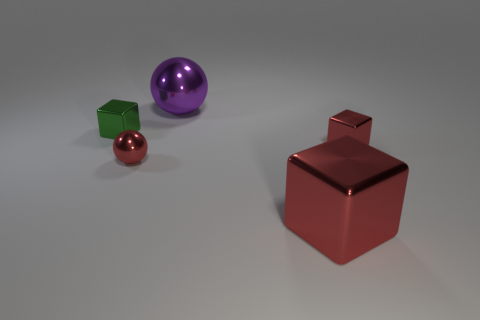Add 2 purple shiny objects. How many objects exist? 7 Subtract all large blocks. How many blocks are left? 2 Subtract all purple spheres. How many spheres are left? 1 Subtract all blocks. How many objects are left? 2 Subtract all blue spheres. Subtract all cyan cylinders. How many spheres are left? 2 Subtract all purple cylinders. How many red balls are left? 1 Subtract all tiny gray matte balls. Subtract all tiny red cubes. How many objects are left? 4 Add 1 big purple shiny spheres. How many big purple shiny spheres are left? 2 Add 3 tiny red spheres. How many tiny red spheres exist? 4 Subtract 0 purple cubes. How many objects are left? 5 